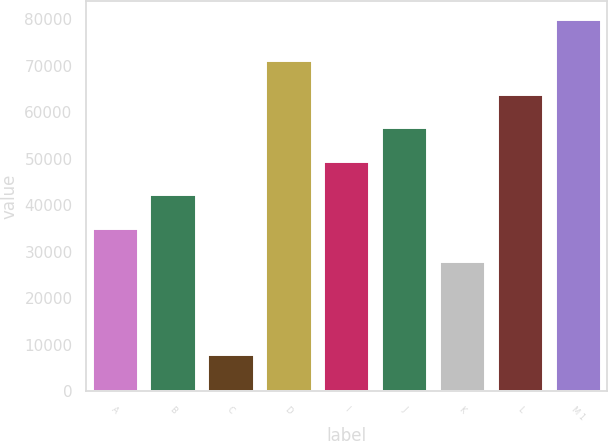Convert chart to OTSL. <chart><loc_0><loc_0><loc_500><loc_500><bar_chart><fcel>A<fcel>B<fcel>C<fcel>D<fcel>I<fcel>J<fcel>K<fcel>L<fcel>M 1<nl><fcel>35200<fcel>42400<fcel>8000<fcel>71200<fcel>49600<fcel>56800<fcel>28000<fcel>64000<fcel>80000<nl></chart> 